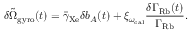Convert formula to latex. <formula><loc_0><loc_0><loc_500><loc_500>\delta \tilde { \Omega } _ { g y r o } ( t ) = \bar { \gamma } _ { X e } \delta b _ { A } ( t ) + \xi _ { \omega _ { c a l } } \frac { \delta \Gamma _ { R b } ( t ) } { \Gamma _ { R b } } .</formula> 